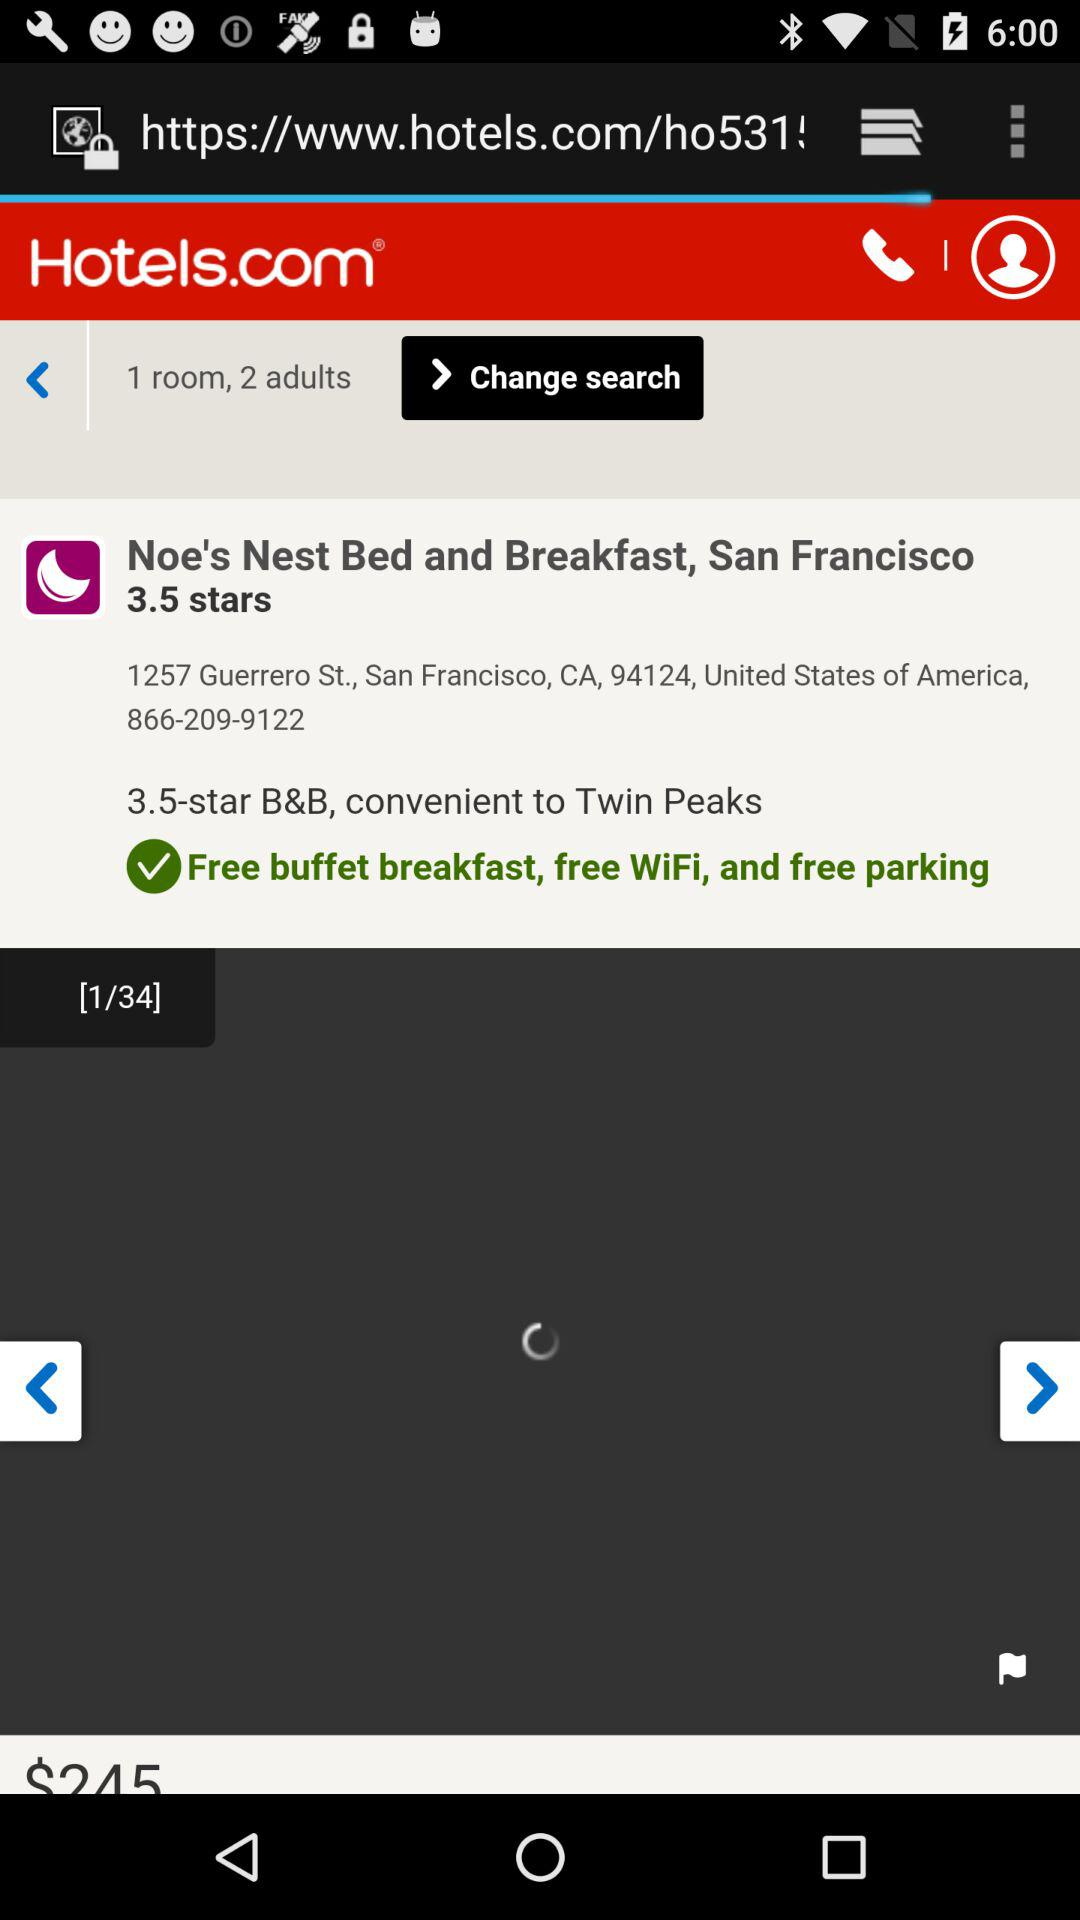What is the star rating of the hotel Noe's Nest Bed and Breakfast, San Francisco? The star rating is 3.5. 